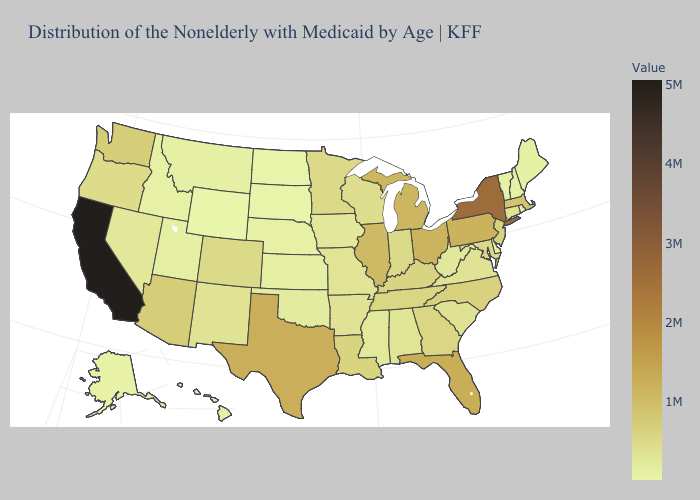Does Michigan have the highest value in the MidWest?
Write a very short answer. No. Which states have the highest value in the USA?
Concise answer only. California. Among the states that border Idaho , does Washington have the highest value?
Answer briefly. Yes. Among the states that border North Carolina , does Tennessee have the highest value?
Quick response, please. No. Does California have the highest value in the USA?
Quick response, please. Yes. Which states have the highest value in the USA?
Give a very brief answer. California. Which states have the highest value in the USA?
Answer briefly. California. Does Rhode Island have the lowest value in the USA?
Short answer required. No. Among the states that border Alabama , does Florida have the highest value?
Answer briefly. Yes. 